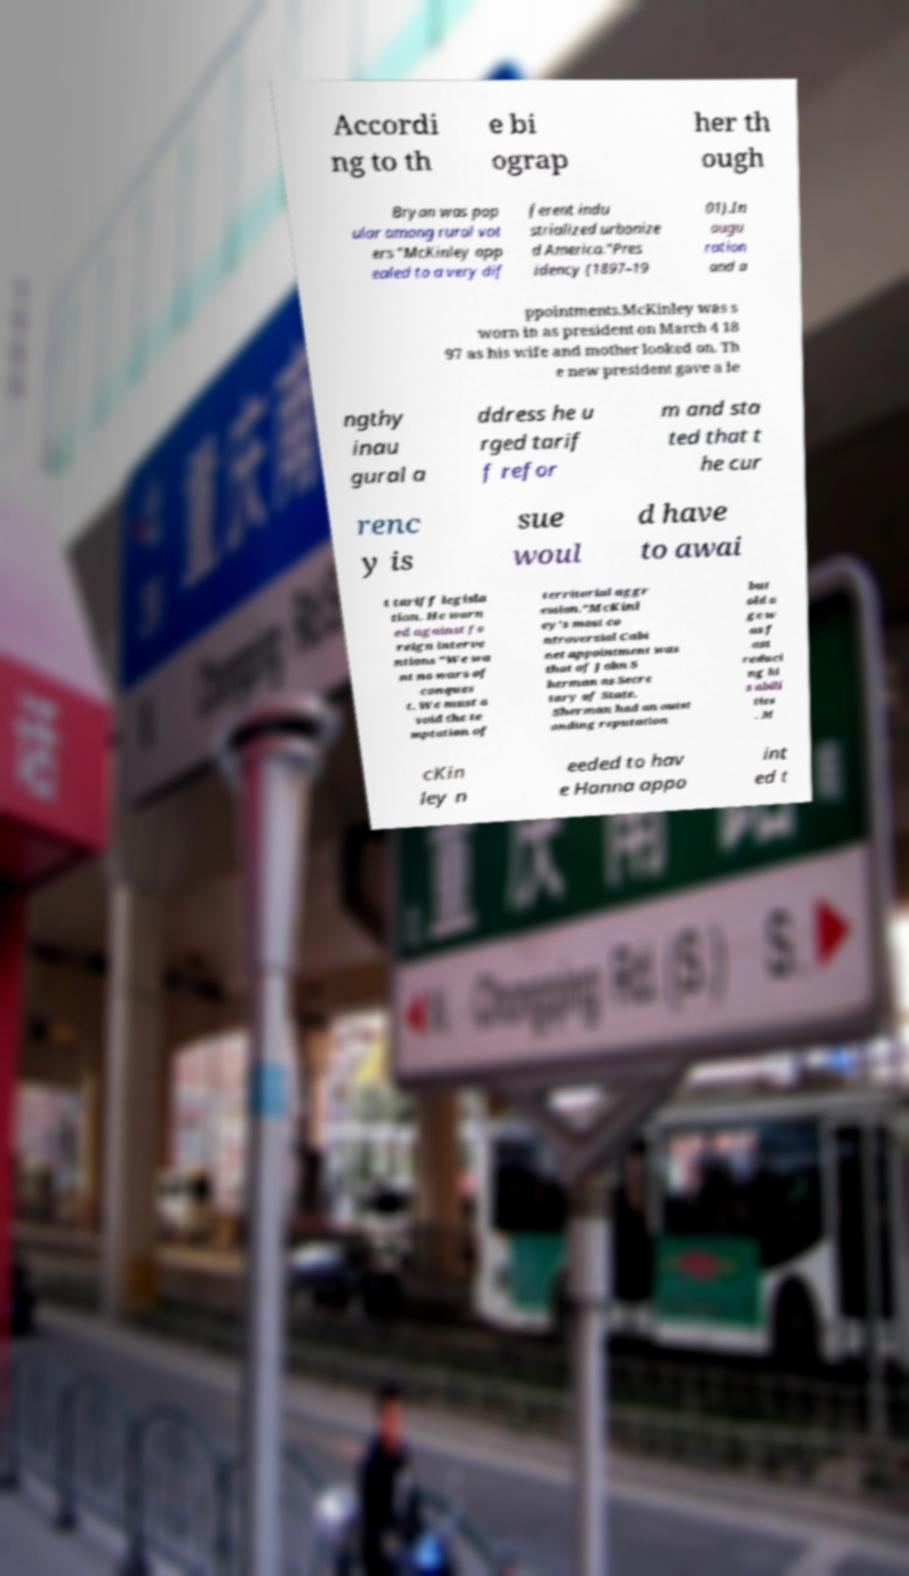Could you assist in decoding the text presented in this image and type it out clearly? Accordi ng to th e bi ograp her th ough Bryan was pop ular among rural vot ers "McKinley app ealed to a very dif ferent indu strialized urbanize d America."Pres idency (1897–19 01).In augu ration and a ppointments.McKinley was s worn in as president on March 4 18 97 as his wife and mother looked on. Th e new president gave a le ngthy inau gural a ddress he u rged tarif f refor m and sta ted that t he cur renc y is sue woul d have to awai t tariff legisla tion. He warn ed against fo reign interve ntions "We wa nt no wars of conques t. We must a void the te mptation of territorial aggr ession."McKinl ey's most co ntroversial Cabi net appointment was that of John S herman as Secre tary of State. Sherman had an outst anding reputation but old a ge w as f ast reduci ng hi s abili ties . M cKin ley n eeded to hav e Hanna appo int ed t 